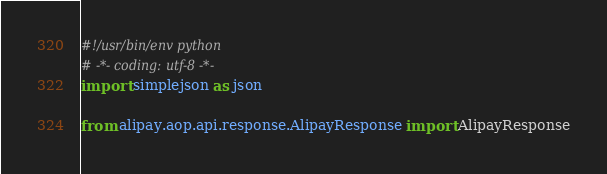Convert code to text. <code><loc_0><loc_0><loc_500><loc_500><_Python_>#!/usr/bin/env python
# -*- coding: utf-8 -*-
import simplejson as json

from alipay.aop.api.response.AlipayResponse import AlipayResponse

</code> 